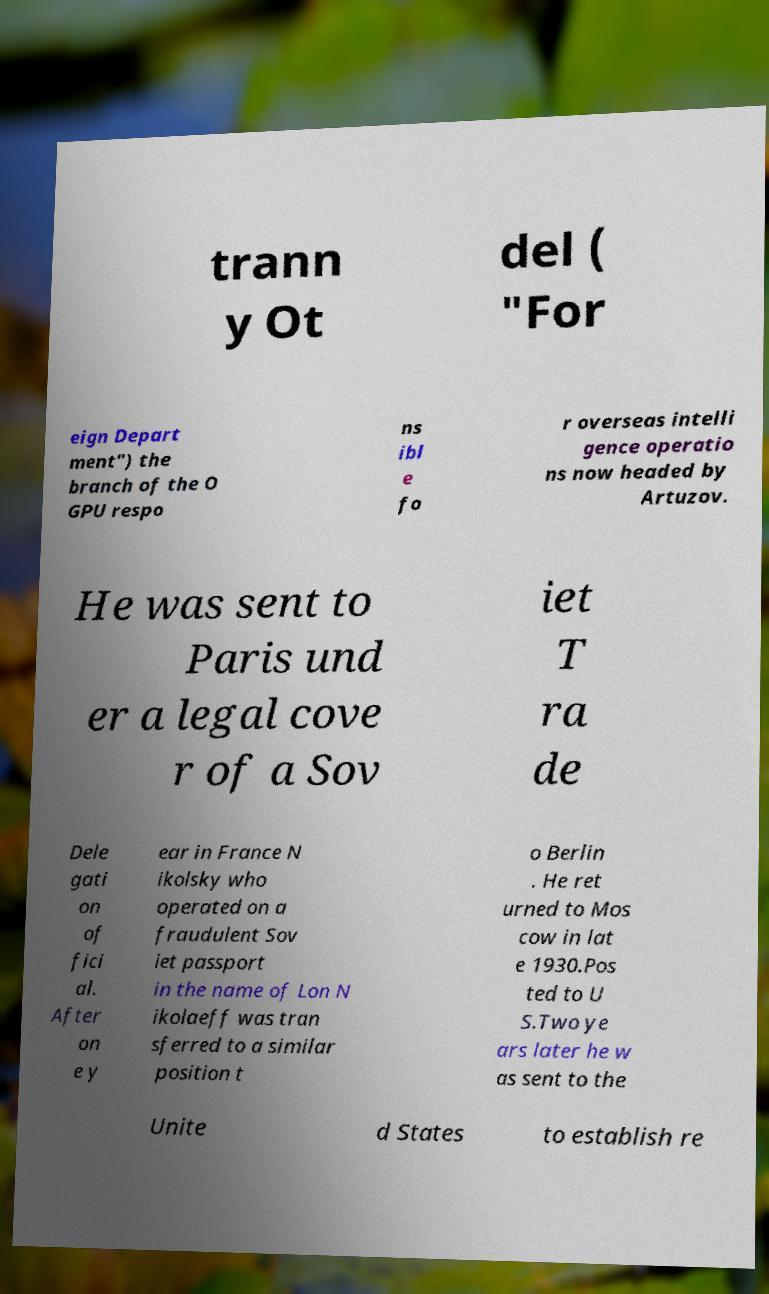Please identify and transcribe the text found in this image. trann y Ot del ( "For eign Depart ment") the branch of the O GPU respo ns ibl e fo r overseas intelli gence operatio ns now headed by Artuzov. He was sent to Paris und er a legal cove r of a Sov iet T ra de Dele gati on of fici al. After on e y ear in France N ikolsky who operated on a fraudulent Sov iet passport in the name of Lon N ikolaeff was tran sferred to a similar position t o Berlin . He ret urned to Mos cow in lat e 1930.Pos ted to U S.Two ye ars later he w as sent to the Unite d States to establish re 